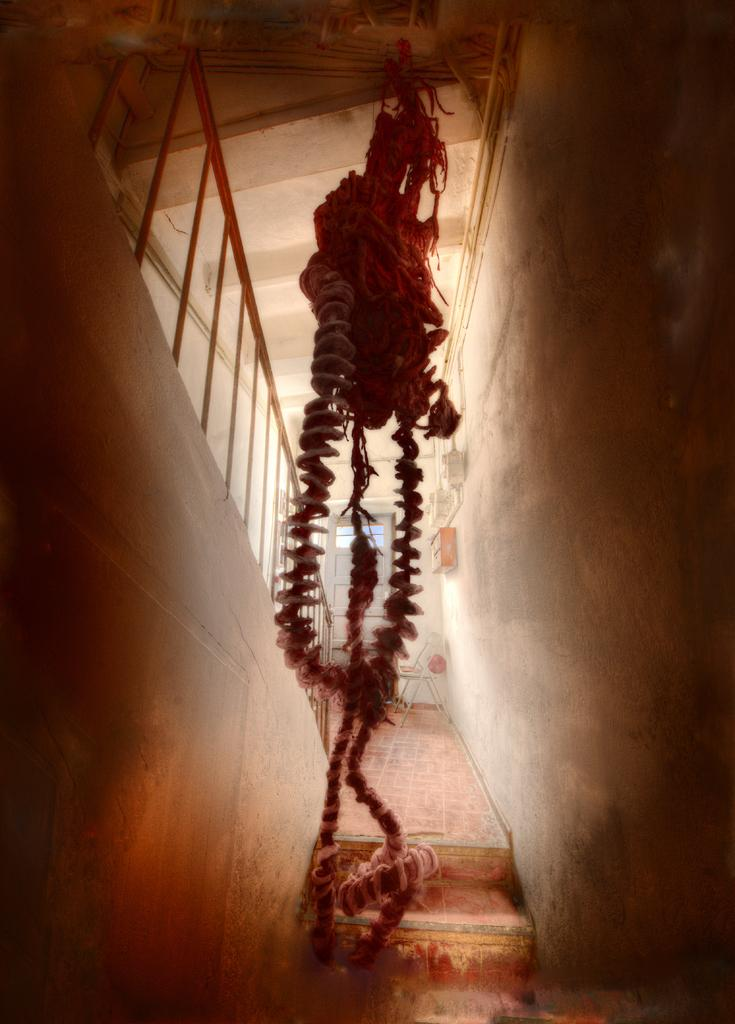What is the main object in the center of the image? There is a rope in the center of the image. What can be seen behind the rope? There are stairs visible behind the rope. What is located on the left side of the image? There is a railing on the left side of the image. How many worms can be seen crawling on the railing in the image? There are no worms present in the image; the railing is the only object mentioned on the left side. 